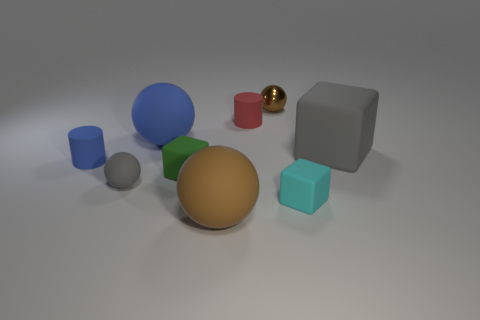Subtract all brown cubes. How many brown balls are left? 2 Subtract all rubber balls. How many balls are left? 1 Subtract all blue balls. How many balls are left? 3 Add 1 tiny brown shiny objects. How many objects exist? 10 Subtract all cyan spheres. Subtract all blue cylinders. How many spheres are left? 4 Subtract all cylinders. How many objects are left? 7 Subtract all matte objects. Subtract all big yellow rubber balls. How many objects are left? 1 Add 3 matte spheres. How many matte spheres are left? 6 Add 2 big brown balls. How many big brown balls exist? 3 Subtract 0 purple cylinders. How many objects are left? 9 